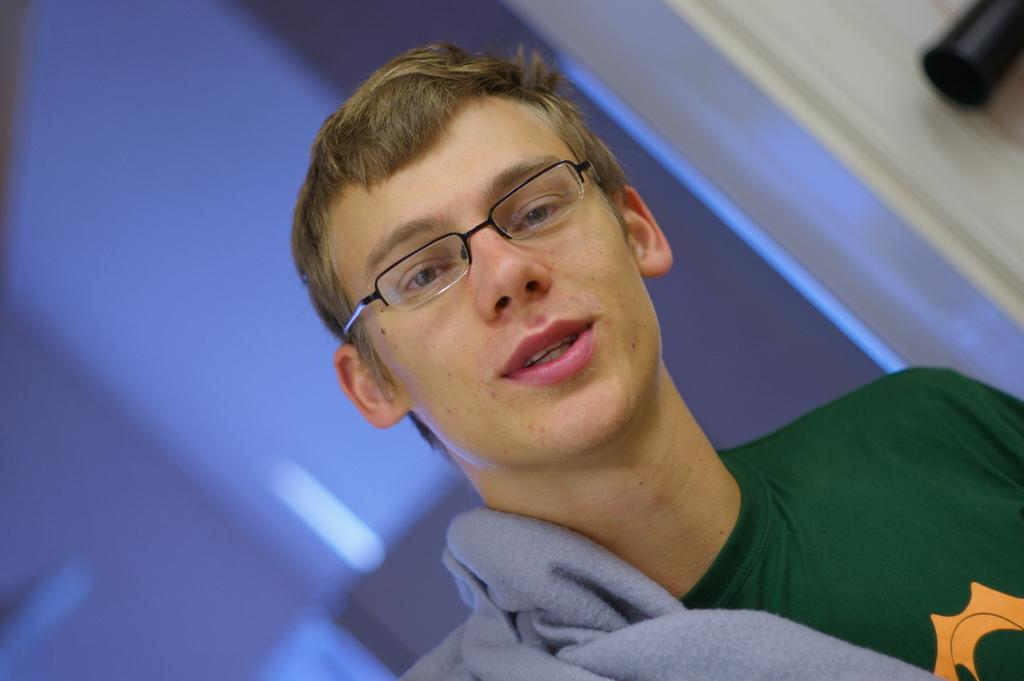Who is the main subject in the image? There is a man in the center of the image. What is the man wearing on his face? The man is wearing glasses. What type of clothing is the man wearing on his upper body? The man is wearing a jacket. What can be seen in the background of the image? There is a door and a wall in the background of the image. What type of mountain can be seen in the background of the image? There is no mountain present in the image; it only features a man, glasses, a jacket, a door, and a wall. What educational institution is the man attending in the image? There is no indication of an educational institution in the image; it only features a man, glasses, a jacket, a door, and a wall. 